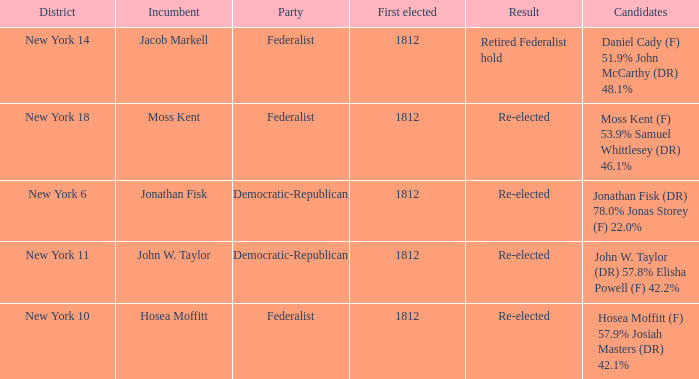Help me parse the entirety of this table. {'header': ['District', 'Incumbent', 'Party', 'First elected', 'Result', 'Candidates'], 'rows': [['New York 14', 'Jacob Markell', 'Federalist', '1812', 'Retired Federalist hold', 'Daniel Cady (F) 51.9% John McCarthy (DR) 48.1%'], ['New York 18', 'Moss Kent', 'Federalist', '1812', 'Re-elected', 'Moss Kent (F) 53.9% Samuel Whittlesey (DR) 46.1%'], ['New York 6', 'Jonathan Fisk', 'Democratic-Republican', '1812', 'Re-elected', 'Jonathan Fisk (DR) 78.0% Jonas Storey (F) 22.0%'], ['New York 11', 'John W. Taylor', 'Democratic-Republican', '1812', 'Re-elected', 'John W. Taylor (DR) 57.8% Elisha Powell (F) 42.2%'], ['New York 10', 'Hosea Moffitt', 'Federalist', '1812', 'Re-elected', 'Hosea Moffitt (F) 57.9% Josiah Masters (DR) 42.1%']]} Name the most first elected 1812.0. 